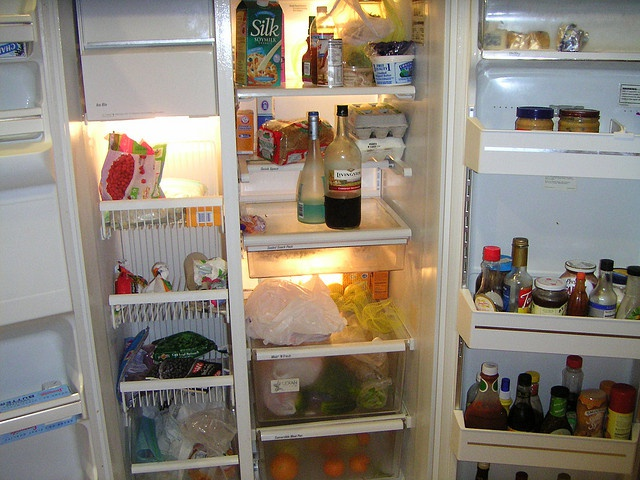Describe the objects in this image and their specific colors. I can see refrigerator in darkgray, gray, black, and ivory tones, bottle in gray, black, olive, and tan tones, bottle in gray and tan tones, bottle in gray, black, maroon, and darkgreen tones, and bottle in gray, black, maroon, and olive tones in this image. 